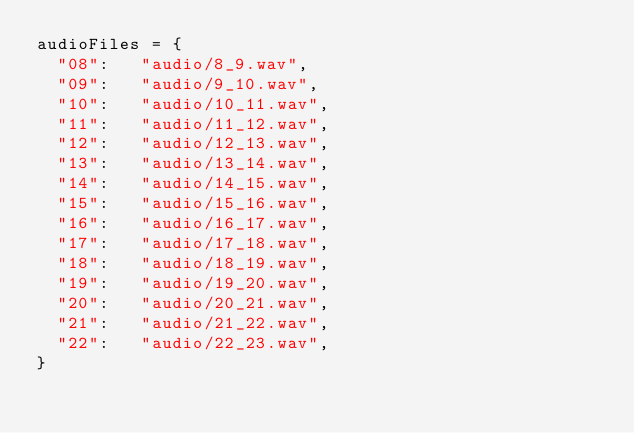Convert code to text. <code><loc_0><loc_0><loc_500><loc_500><_Python_>audioFiles = {
	"08": 	"audio/8_9.wav",	
	"09": 	"audio/9_10.wav",	
	"10": 	"audio/10_11.wav",
	"11": 	"audio/11_12.wav",	
	"12": 	"audio/12_13.wav",	
	"13": 	"audio/13_14.wav",	
	"14": 	"audio/14_15.wav",	
	"15": 	"audio/15_16.wav",	
	"16": 	"audio/16_17.wav",	
	"17": 	"audio/17_18.wav",	
	"18": 	"audio/18_19.wav",	
	"19": 	"audio/19_20.wav",	
	"20": 	"audio/20_21.wav",	
	"21": 	"audio/21_22.wav",	
	"22": 	"audio/22_23.wav",
}</code> 